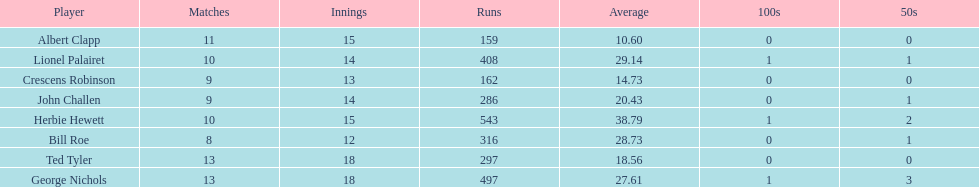How many more runs does john have than albert? 127. Could you parse the entire table as a dict? {'header': ['Player', 'Matches', 'Innings', 'Runs', 'Average', '100s', '50s'], 'rows': [['Albert Clapp', '11', '15', '159', '10.60', '0', '0'], ['Lionel Palairet', '10', '14', '408', '29.14', '1', '1'], ['Crescens Robinson', '9', '13', '162', '14.73', '0', '0'], ['John Challen', '9', '14', '286', '20.43', '0', '1'], ['Herbie Hewett', '10', '15', '543', '38.79', '1', '2'], ['Bill Roe', '8', '12', '316', '28.73', '0', '1'], ['Ted Tyler', '13', '18', '297', '18.56', '0', '0'], ['George Nichols', '13', '18', '497', '27.61', '1', '3']]} 